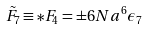<formula> <loc_0><loc_0><loc_500><loc_500>{ \tilde { F } } _ { 7 } \equiv * F _ { 4 } = \pm 6 N a ^ { 6 } \epsilon _ { 7 }</formula> 